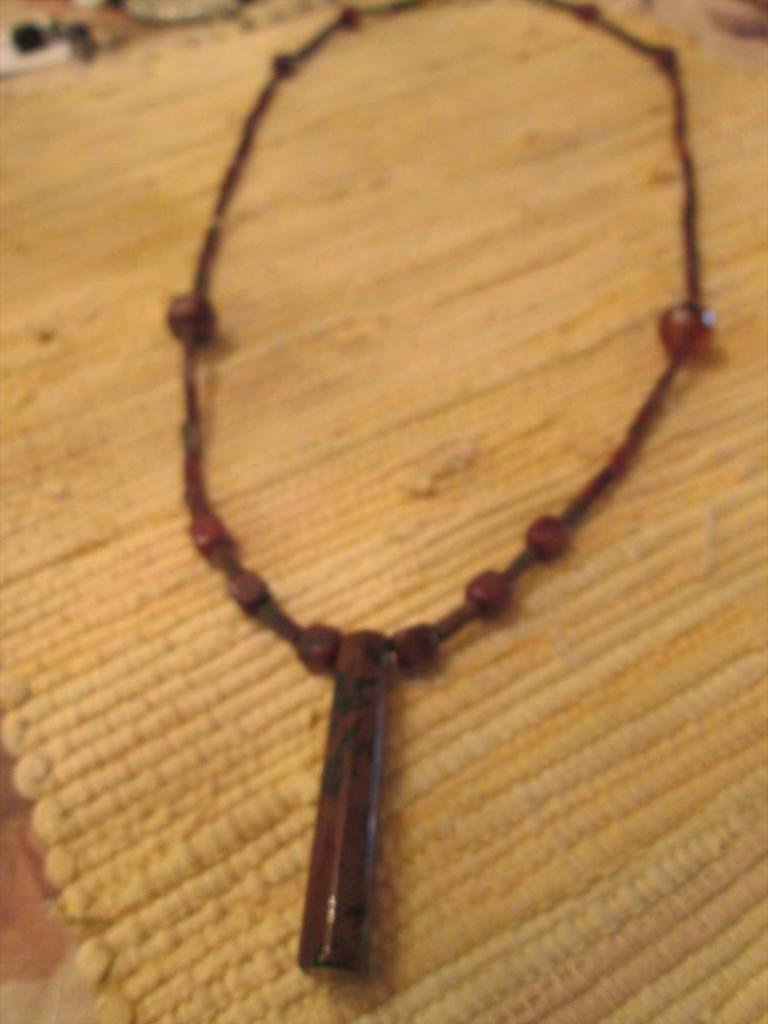What is the main object in the picture? The main object in the picture is a chain. What is attached to the chain? The chain has a locket attached to it. What is the color of the surface the chain and locket are placed on? The chain and locket are placed on a yellow colored surface. What type of silk material is used to make the pen in the image? There is no pen present in the image, so it is not possible to determine what type of silk material might be used to make it. 